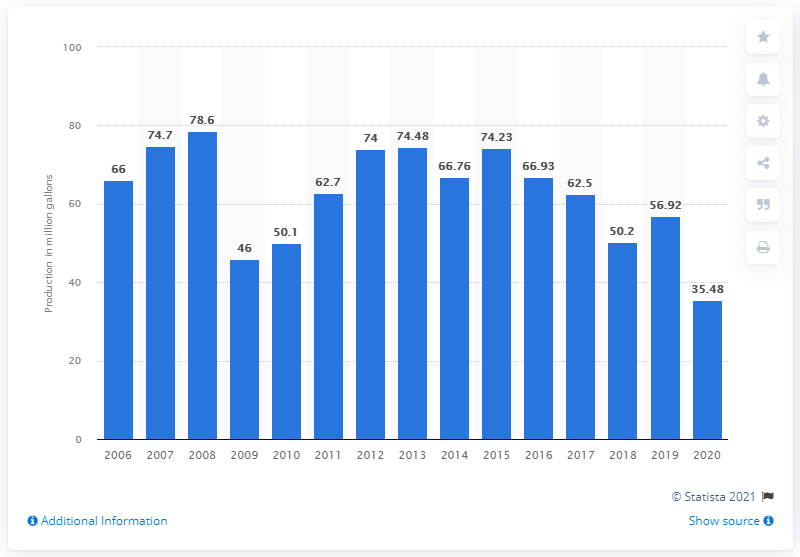Identify some key points in this picture. In 2020, the United States produced approximately 35.48 million gallons of frozen yogurt. 